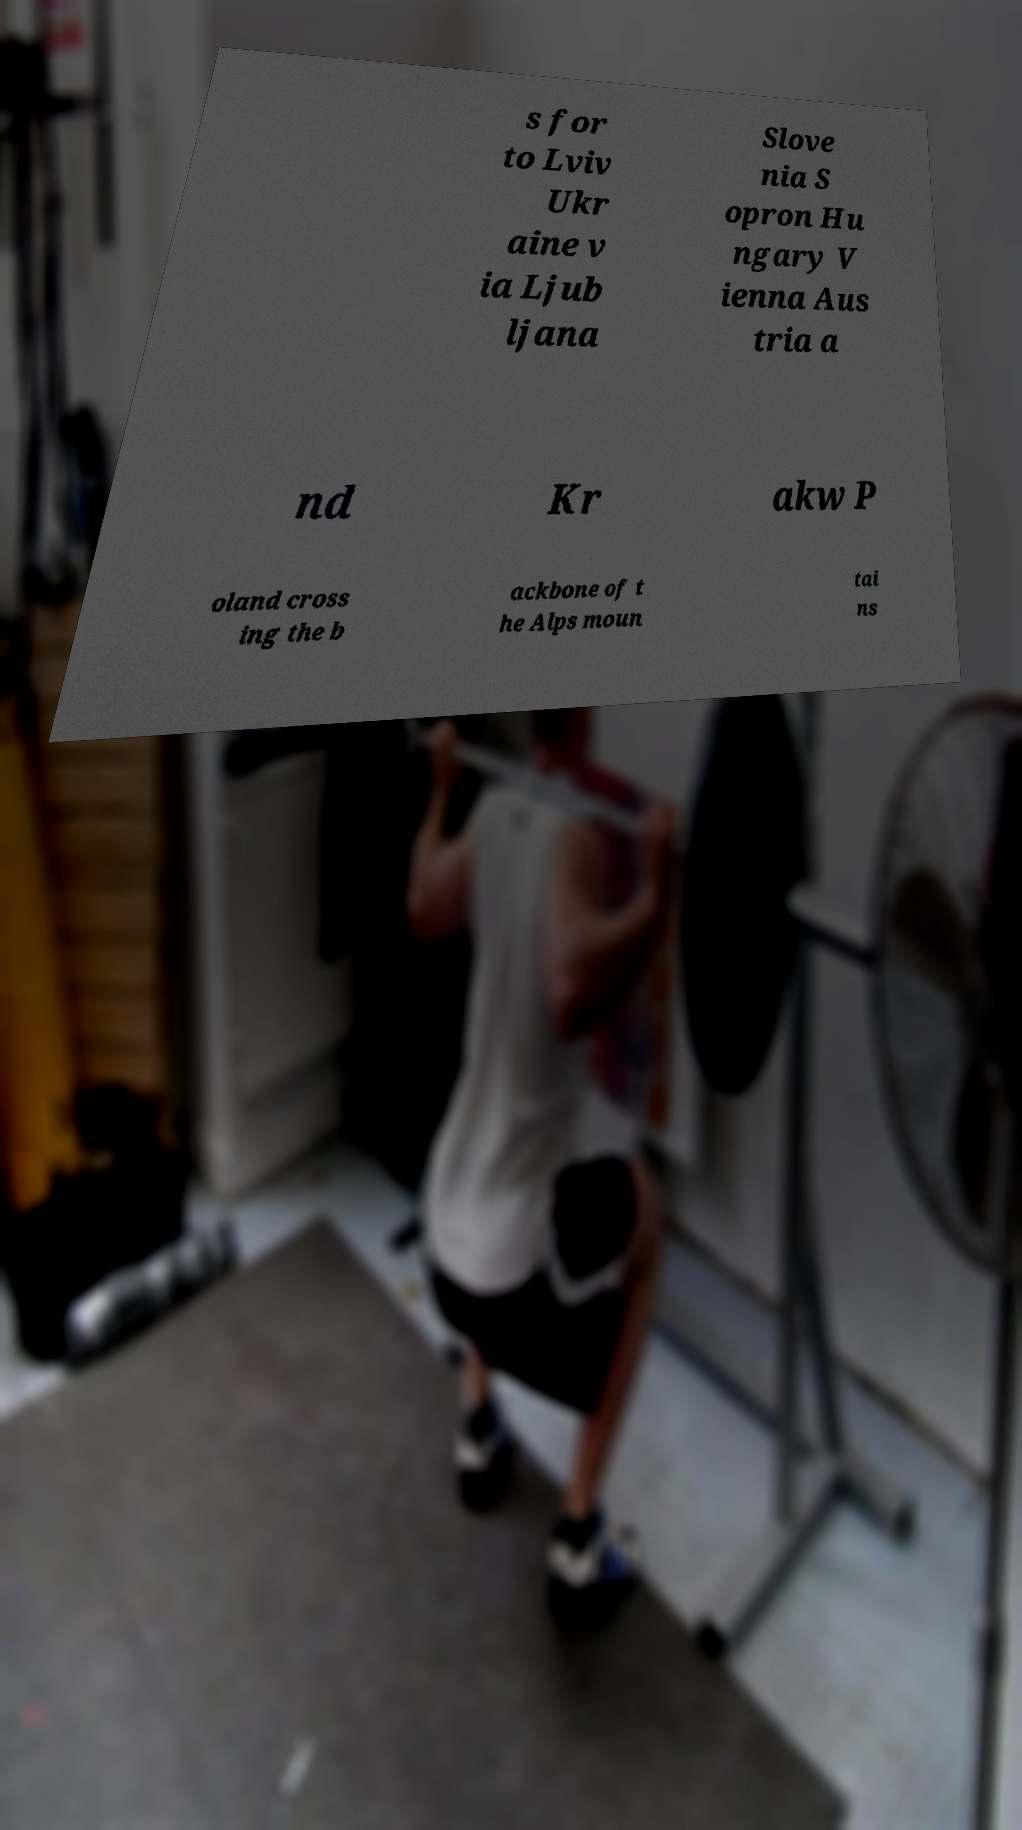What messages or text are displayed in this image? I need them in a readable, typed format. s for to Lviv Ukr aine v ia Ljub ljana Slove nia S opron Hu ngary V ienna Aus tria a nd Kr akw P oland cross ing the b ackbone of t he Alps moun tai ns 